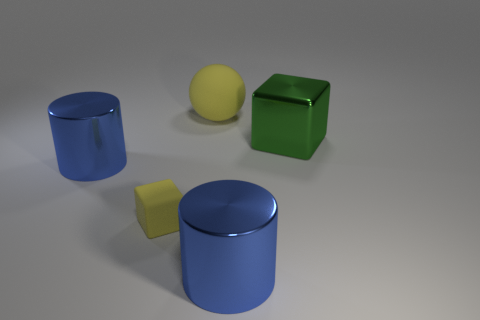Is there anything else that has the same material as the sphere?
Offer a very short reply. Yes. There is a large object that is on the right side of the large rubber object and on the left side of the large metallic block; what is its material?
Offer a terse response. Metal. There is a large thing that is the same material as the tiny thing; what is its shape?
Make the answer very short. Sphere. Are there any other things that have the same color as the rubber ball?
Your answer should be very brief. Yes. Are there more small rubber things right of the large rubber sphere than tiny rubber blocks?
Your response must be concise. No. What material is the large sphere?
Your response must be concise. Rubber. How many blocks are the same size as the green metal object?
Ensure brevity in your answer.  0. Are there an equal number of green metallic objects that are left of the big sphere and green cubes in front of the metal block?
Your response must be concise. Yes. Does the tiny yellow block have the same material as the big green object?
Your response must be concise. No. Are there any tiny yellow rubber things that are in front of the small matte thing in front of the ball?
Your answer should be compact. No. 